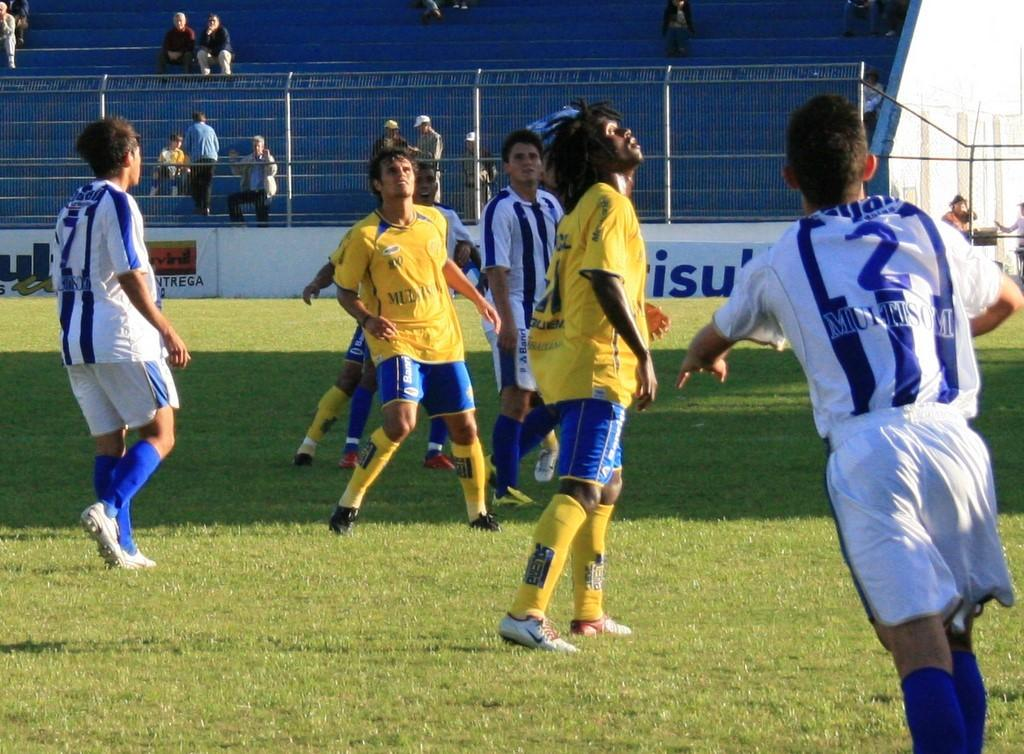<image>
Share a concise interpretation of the image provided. Soccer player in white and blue stripe shirt that has Muitisom in blue letters. 